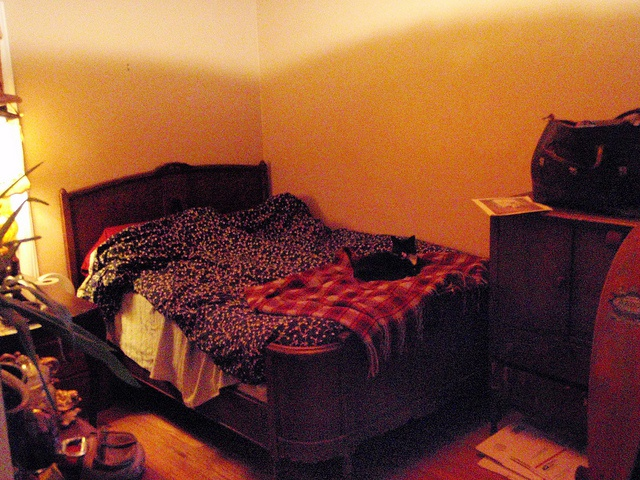Describe the objects in this image and their specific colors. I can see bed in tan, black, maroon, and brown tones, handbag in tan, black, maroon, and brown tones, and cat in tan, black, maroon, and brown tones in this image. 